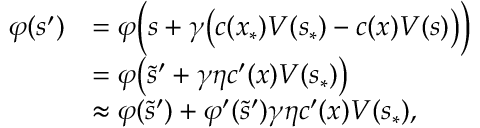<formula> <loc_0><loc_0><loc_500><loc_500>\begin{array} { r l } { \varphi ( s ^ { \prime } ) } & { = \varphi \left ( s + \gamma \left ( c ( x _ { \ast } ) V ( s _ { \ast } ) - c ( x ) V ( s ) \right ) \right ) } \\ & { = \varphi \left ( \tilde { s } ^ { \prime } + \gamma \eta c ^ { \prime } ( x ) V ( s _ { \ast } ) \right ) } \\ & { \approx \varphi ( \tilde { s } ^ { \prime } ) + \varphi ^ { \prime } ( \tilde { s } ^ { \prime } ) \gamma \eta c ^ { \prime } ( x ) V ( s _ { \ast } ) , } \end{array}</formula> 